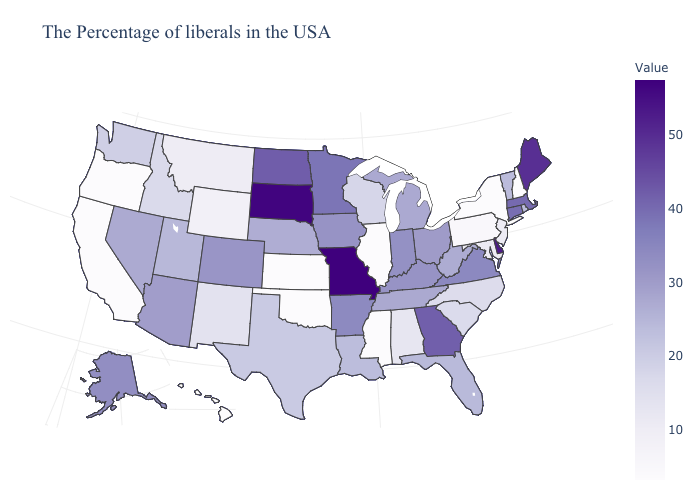Among the states that border Montana , which have the highest value?
Give a very brief answer. South Dakota. Does West Virginia have a lower value than New Hampshire?
Quick response, please. No. Among the states that border New Jersey , does New York have the lowest value?
Give a very brief answer. Yes. Does Missouri have the highest value in the USA?
Quick response, please. Yes. 